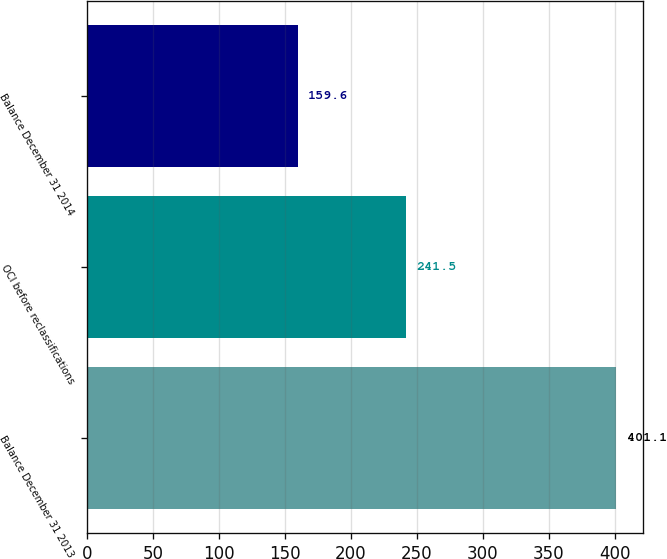Convert chart to OTSL. <chart><loc_0><loc_0><loc_500><loc_500><bar_chart><fcel>Balance December 31 2013<fcel>OCI before reclassifications<fcel>Balance December 31 2014<nl><fcel>401.1<fcel>241.5<fcel>159.6<nl></chart> 